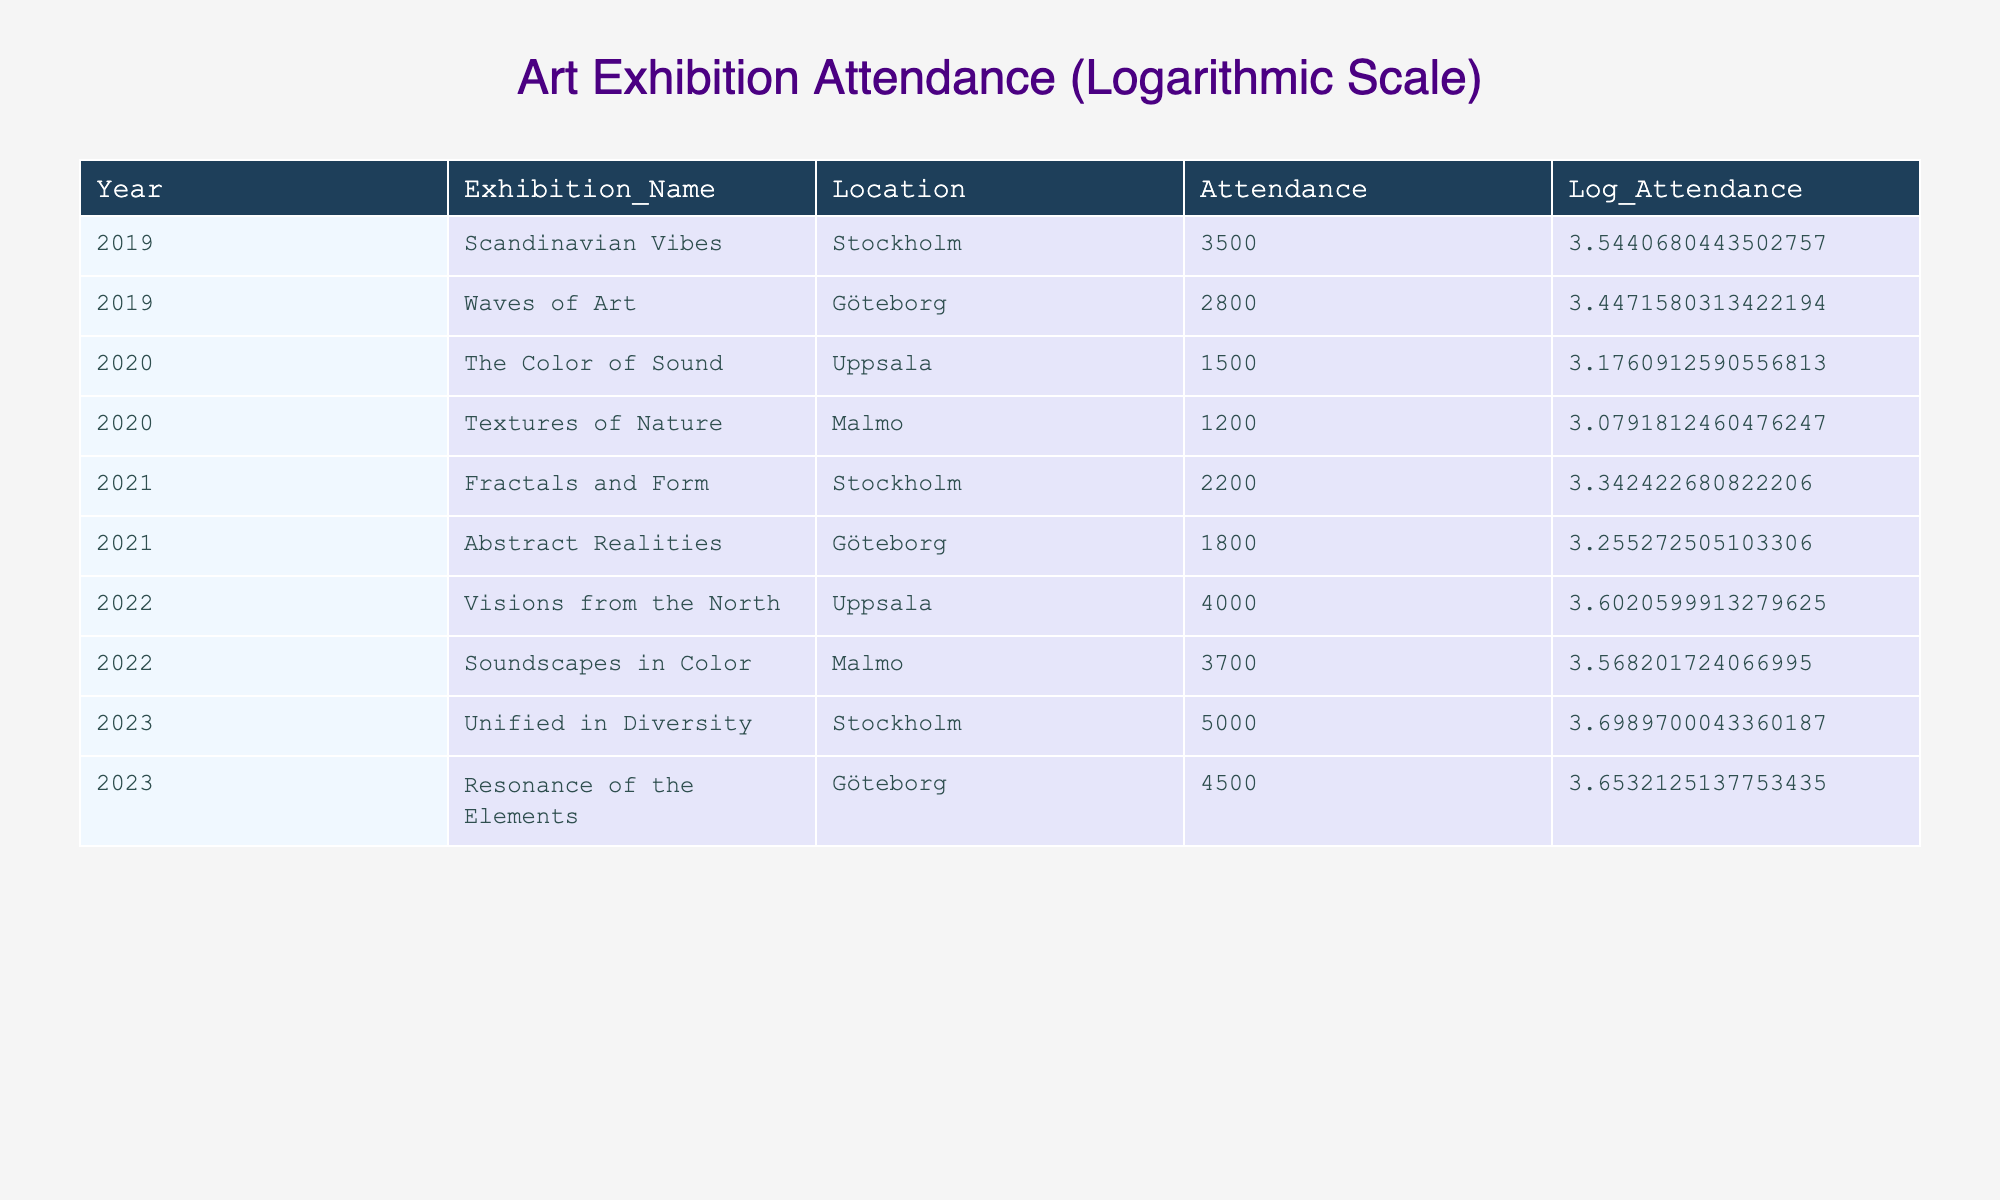What was the attendance for the exhibition "Unified in Diversity"? The attendance for "Unified in Diversity," which took place in 2023 in Stockholm, is listed directly in the table as 5000.
Answer: 5000 In which year did the exhibition "Visions from the North" occur, and what was its attendance? The exhibition "Visions from the North" occurred in 2022, and the attendance is noted in the table as 4000.
Answer: 2022, 4000 What is the total attendance for exhibitions held in Göteborg? The exhibitions held in Göteborg were "Waves of Art" (2800), "Abstract Realities" (1800), and "Resonance of the Elements" (4500). Summing these, the total attendance is 2800 + 1800 + 4500 = 9100.
Answer: 9100 What is the average attendance across all exhibitions in 2020? The exhibitions in 2020 were "The Color of Sound" (1500) and "Textures of Nature" (1200). To find the average, we first sum the attendances: 1500 + 1200 = 2700, and then divide by 2 (the number of exhibitions) to get the average: 2700 / 2 = 1350.
Answer: 1350 Was the attendance for "Fractals and Form" greater than 2000? The attendance for "Fractals and Form" is listed as 2200, which is indeed greater than 2000.
Answer: Yes Which location had the highest attendance in the year 2023? In 2023, the highest attendance was for the exhibition "Unified in Diversity" in Stockholm which had an attendance of 5000, higher than "Resonance of the Elements" in Göteborg with 4500.
Answer: Stockholm How much more did the attendance for "Soundscapes in Color" exceed the attendance for "Fractals and Form"? The attendance for "Soundscapes in Color" in 2022 was 3700, and the attendance for "Fractals and Form" in 2021 was 2200. The difference is 3700 - 2200 = 1500.
Answer: 1500 What percentage of the total attendance from all exhibitions in 2022 was represented by "Visions from the North"? The total attendance for 2022 was 4000 (for "Visions from the North") + 3700 (for "Soundscapes in Color") = 7700. The percentage represented by "Visions from the North" is (4000 / 7700) * 100, which is approximately 51.95%.
Answer: Approximately 51.95% 